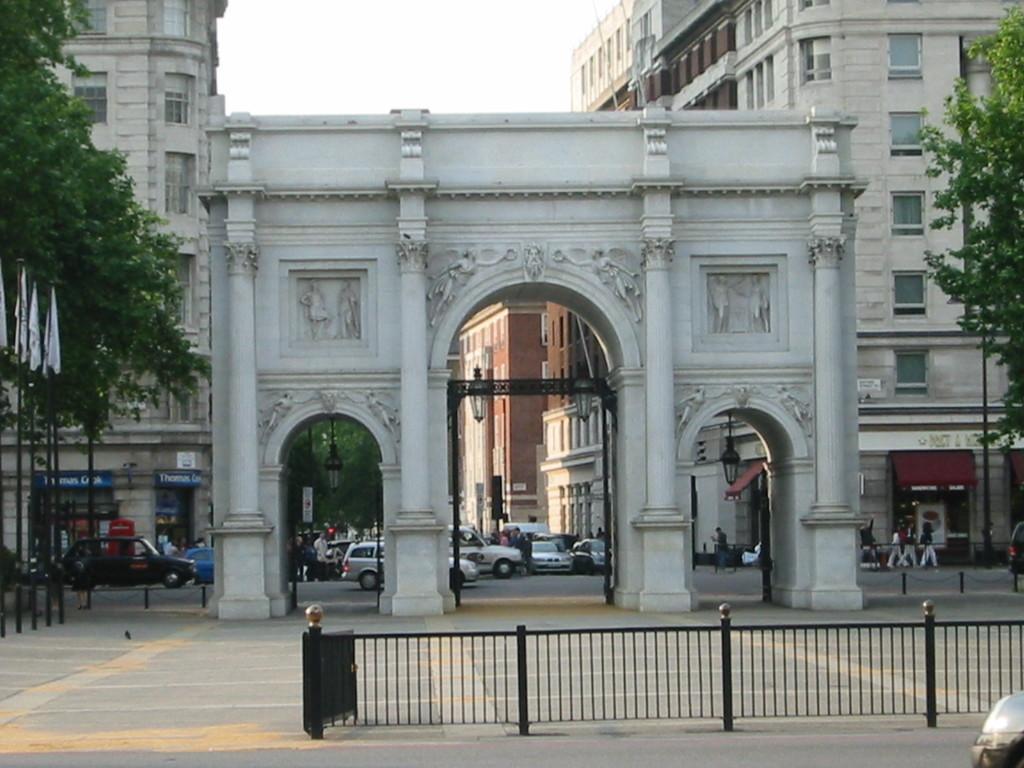How would you summarize this image in a sentence or two? In this image, we can see people and vehicles on the road and in the background, there are flags, poles, trees, buildings, lights and some other poles and some boards. In the front, we can see railing. At the top, there is sky and at the bottom, there is road. 